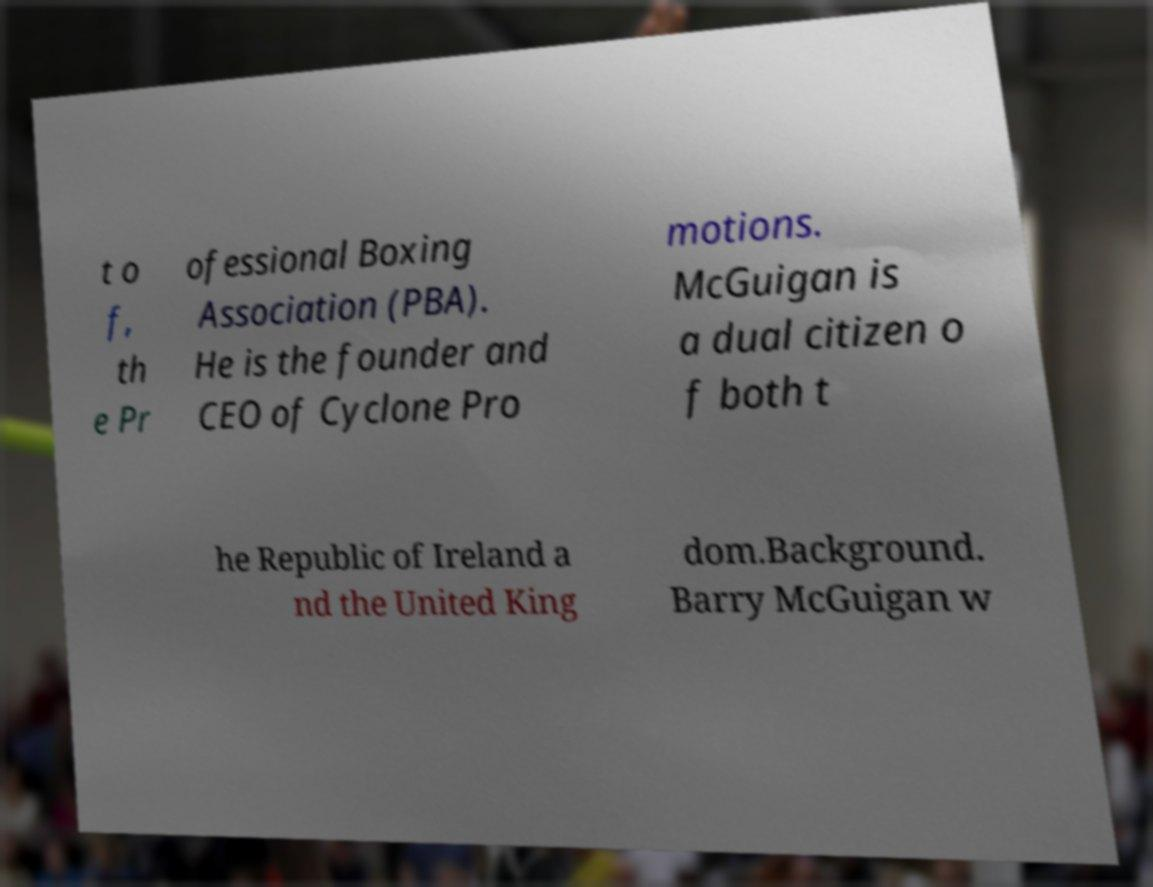Could you extract and type out the text from this image? t o f, th e Pr ofessional Boxing Association (PBA). He is the founder and CEO of Cyclone Pro motions. McGuigan is a dual citizen o f both t he Republic of Ireland a nd the United King dom.Background. Barry McGuigan w 